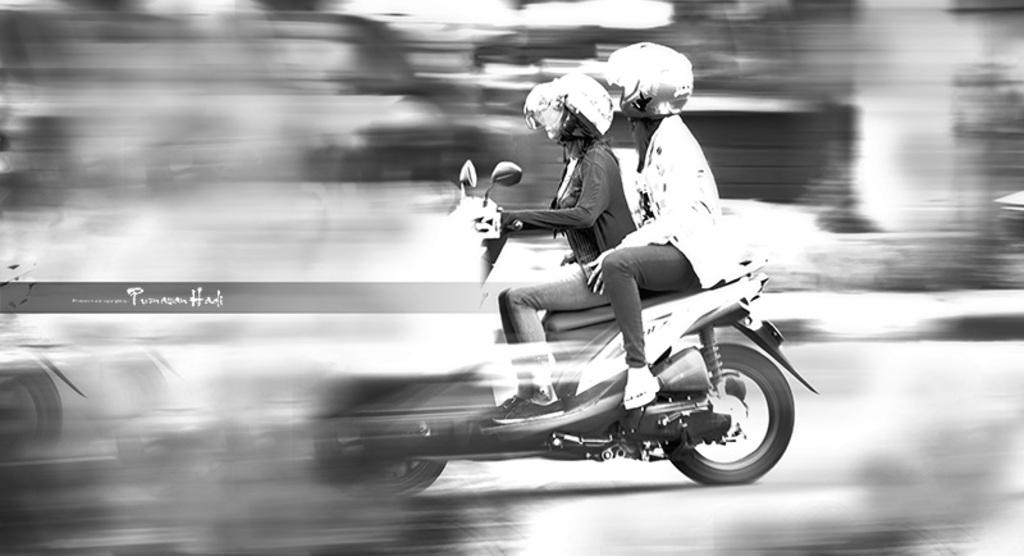How many people are in the image? There are two women in the image. What are the women doing in the image? The women are riding a bike. What safety precautions are the women taking while riding the bike? The women are wearing helmets. Where is the bike located in the image? The bike is on a road. What type of pear is being used as a comfort item for the women while riding the bike? There is no pear present in the image, and the women are not using any comfort items while riding the bike. 